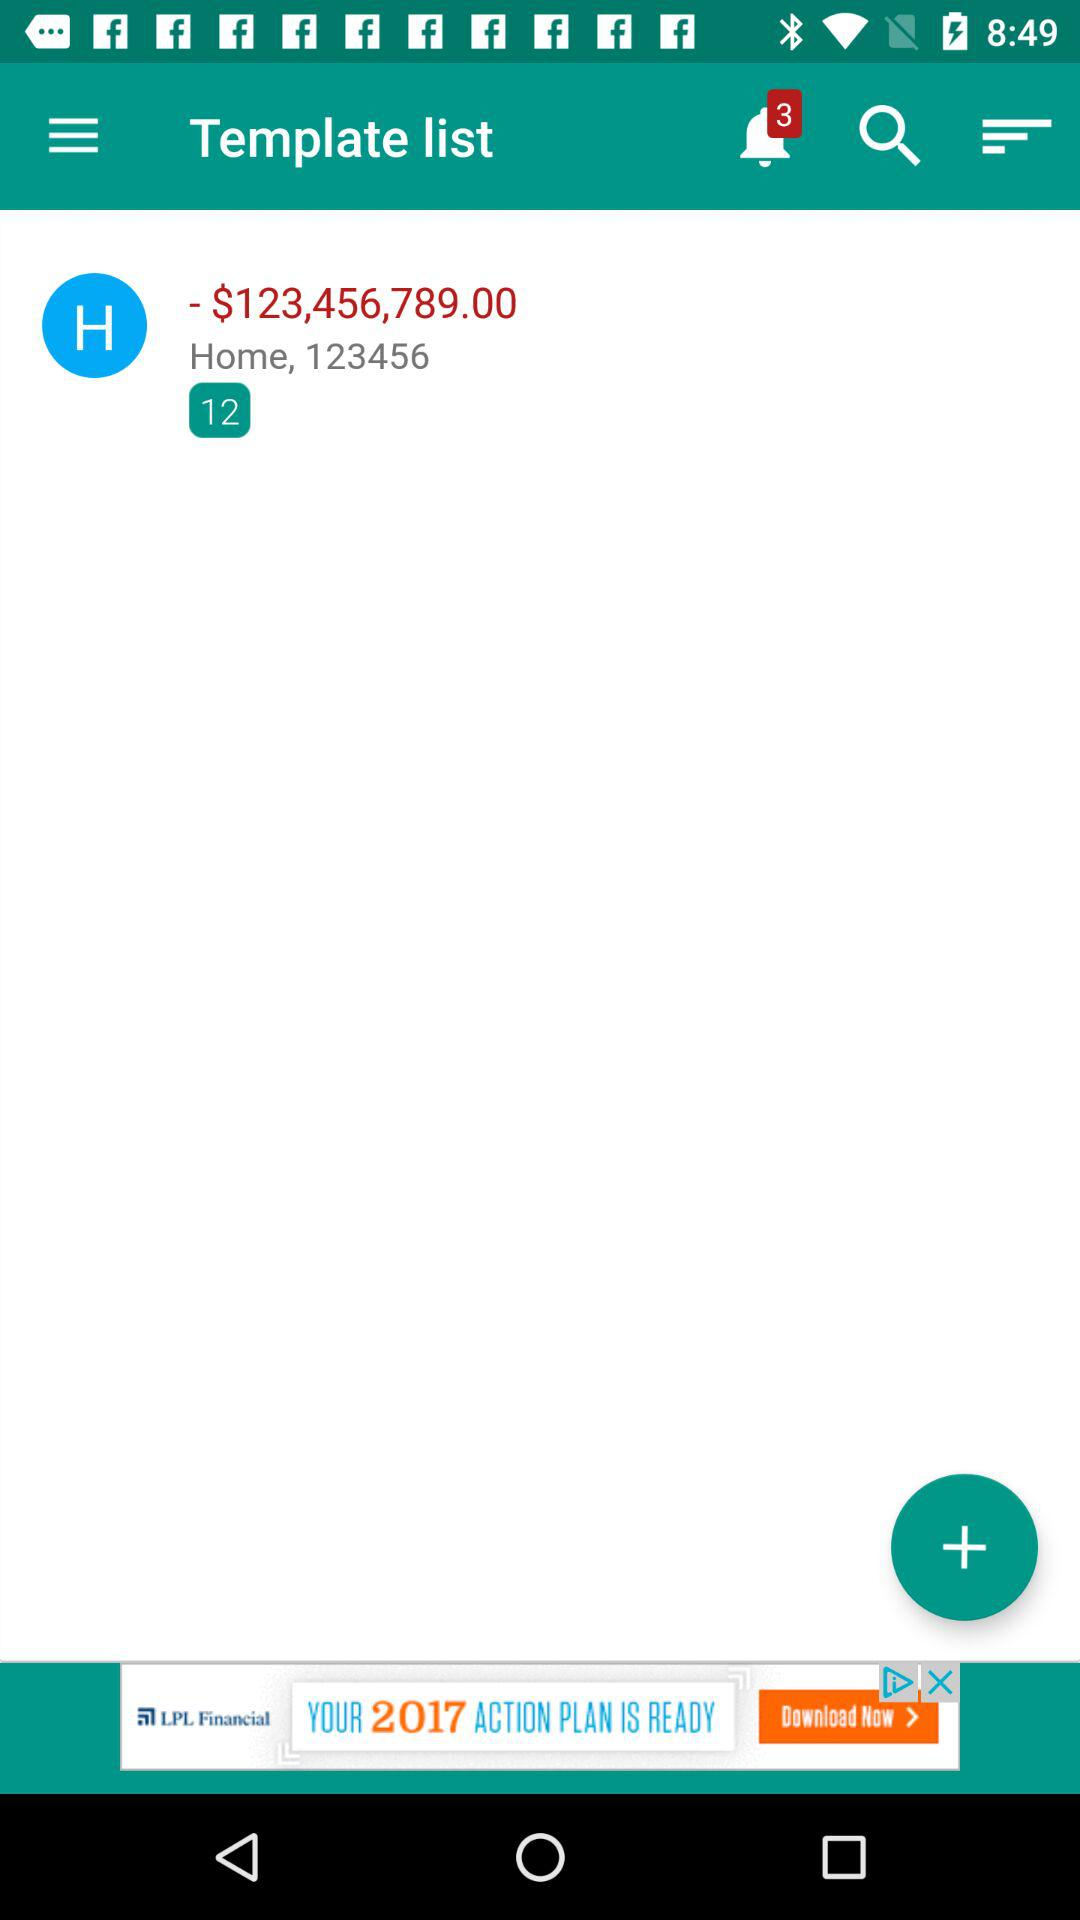How many notifications are there? There are 3 notifications. 